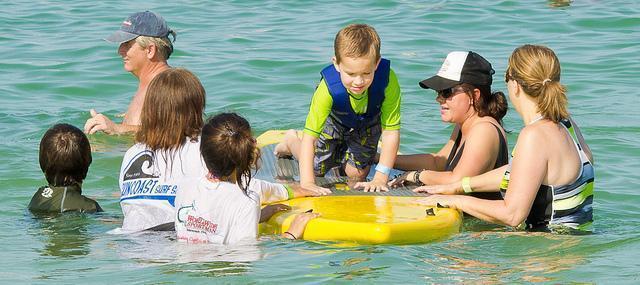How many people are wearing hats?
Give a very brief answer. 2. How many surfboards can be seen?
Give a very brief answer. 1. How many people can be seen?
Give a very brief answer. 7. 